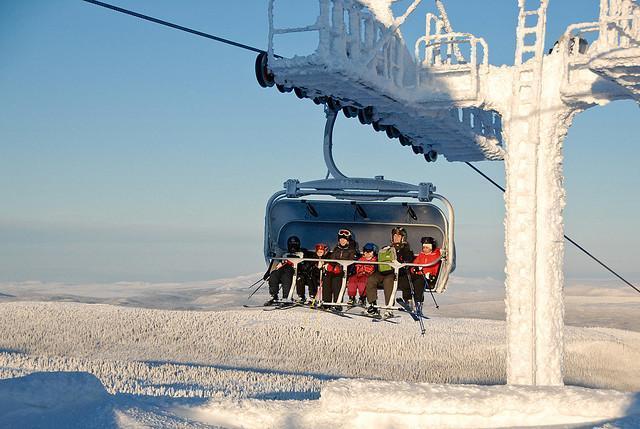How many people are on the lift?
Give a very brief answer. 6. How many people are on the ski lift?
Give a very brief answer. 6. How many toilet covers are there?
Give a very brief answer. 0. 